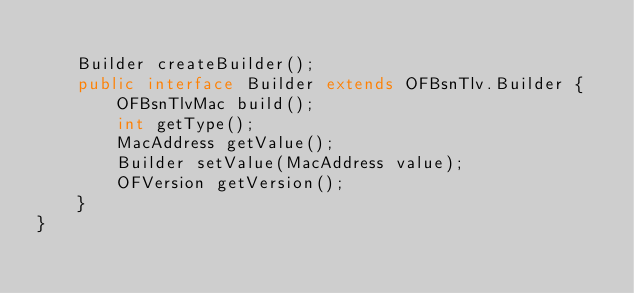<code> <loc_0><loc_0><loc_500><loc_500><_Java_>
    Builder createBuilder();
    public interface Builder extends OFBsnTlv.Builder {
        OFBsnTlvMac build();
        int getType();
        MacAddress getValue();
        Builder setValue(MacAddress value);
        OFVersion getVersion();
    }
}
</code> 